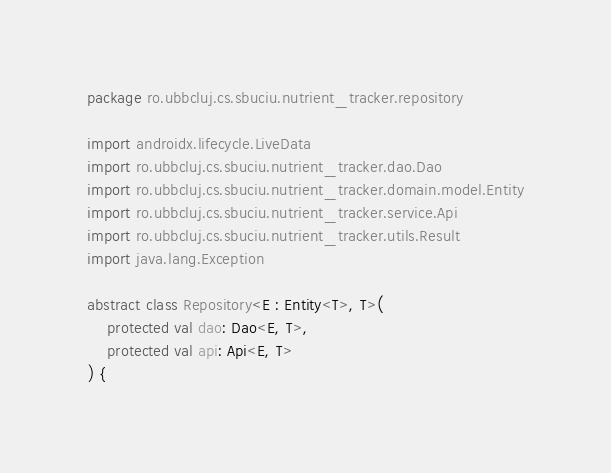Convert code to text. <code><loc_0><loc_0><loc_500><loc_500><_Kotlin_>package ro.ubbcluj.cs.sbuciu.nutrient_tracker.repository

import androidx.lifecycle.LiveData
import ro.ubbcluj.cs.sbuciu.nutrient_tracker.dao.Dao
import ro.ubbcluj.cs.sbuciu.nutrient_tracker.domain.model.Entity
import ro.ubbcluj.cs.sbuciu.nutrient_tracker.service.Api
import ro.ubbcluj.cs.sbuciu.nutrient_tracker.utils.Result
import java.lang.Exception

abstract class Repository<E : Entity<T>, T>(
    protected val dao: Dao<E, T>,
    protected val api: Api<E, T>
) {
</code> 